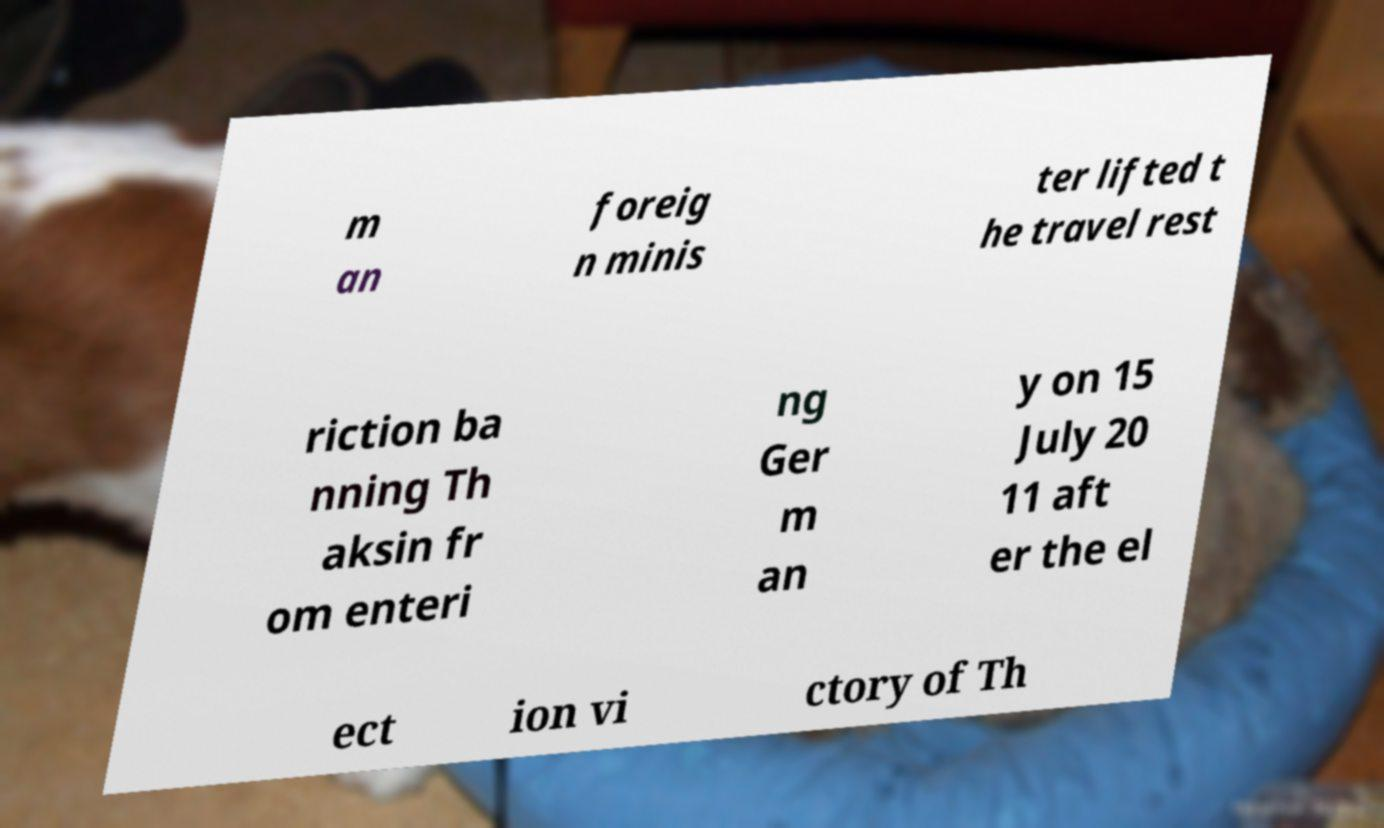There's text embedded in this image that I need extracted. Can you transcribe it verbatim? m an foreig n minis ter lifted t he travel rest riction ba nning Th aksin fr om enteri ng Ger m an y on 15 July 20 11 aft er the el ect ion vi ctory of Th 